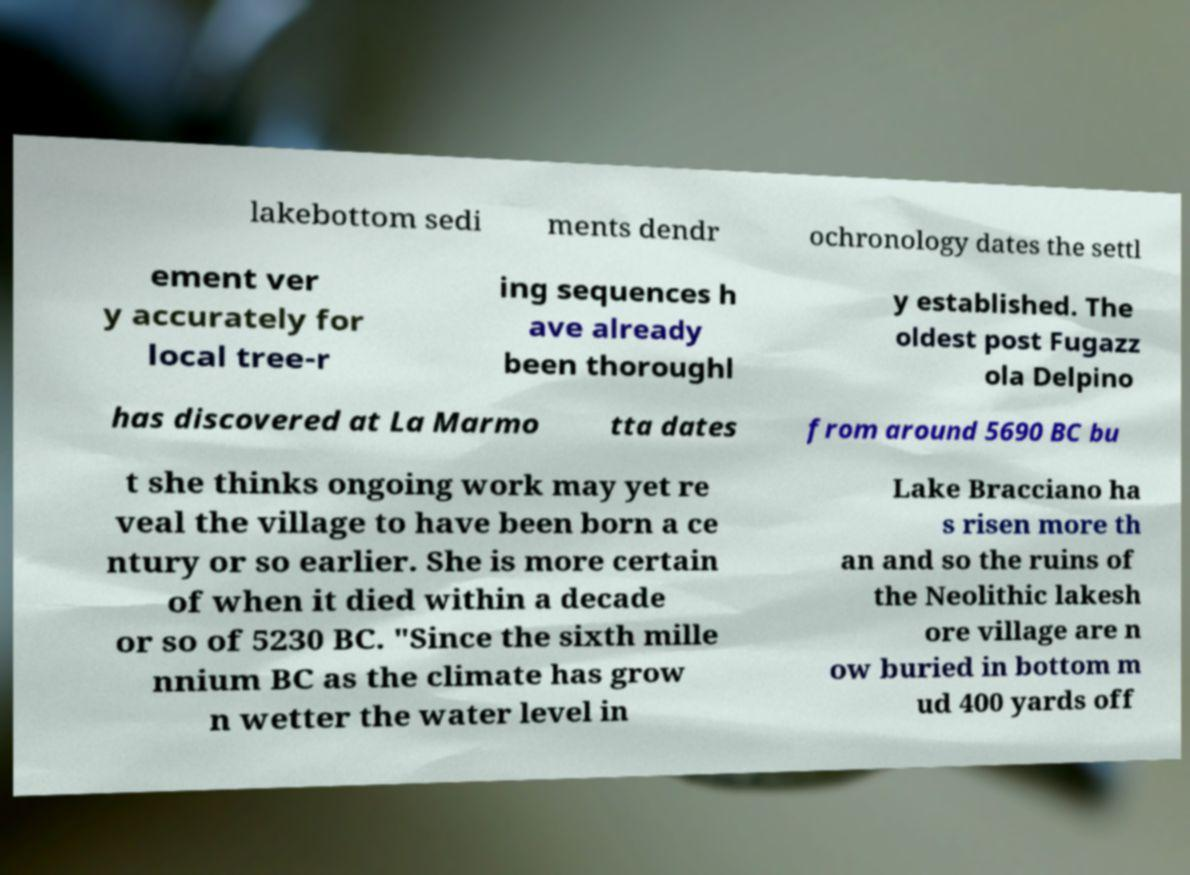For documentation purposes, I need the text within this image transcribed. Could you provide that? lakebottom sedi ments dendr ochronology dates the settl ement ver y accurately for local tree-r ing sequences h ave already been thoroughl y established. The oldest post Fugazz ola Delpino has discovered at La Marmo tta dates from around 5690 BC bu t she thinks ongoing work may yet re veal the village to have been born a ce ntury or so earlier. She is more certain of when it died within a decade or so of 5230 BC. "Since the sixth mille nnium BC as the climate has grow n wetter the water level in Lake Bracciano ha s risen more th an and so the ruins of the Neolithic lakesh ore village are n ow buried in bottom m ud 400 yards off 